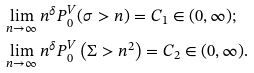Convert formula to latex. <formula><loc_0><loc_0><loc_500><loc_500>& \lim _ { n \to \infty } n ^ { \delta } P _ { 0 } ^ { V } ( \sigma > n ) = C _ { 1 } \in ( 0 , \infty ) ; \\ & \lim _ { n \to \infty } n ^ { \delta } P _ { 0 } ^ { V } \left ( \Sigma > n ^ { 2 } \right ) = C _ { 2 } \in ( 0 , \infty ) .</formula> 